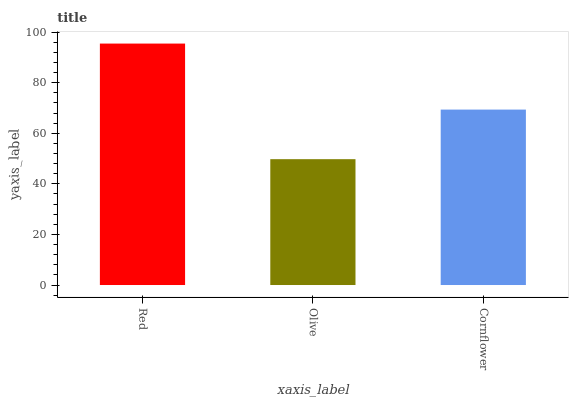Is Olive the minimum?
Answer yes or no. Yes. Is Red the maximum?
Answer yes or no. Yes. Is Cornflower the minimum?
Answer yes or no. No. Is Cornflower the maximum?
Answer yes or no. No. Is Cornflower greater than Olive?
Answer yes or no. Yes. Is Olive less than Cornflower?
Answer yes or no. Yes. Is Olive greater than Cornflower?
Answer yes or no. No. Is Cornflower less than Olive?
Answer yes or no. No. Is Cornflower the high median?
Answer yes or no. Yes. Is Cornflower the low median?
Answer yes or no. Yes. Is Red the high median?
Answer yes or no. No. Is Olive the low median?
Answer yes or no. No. 